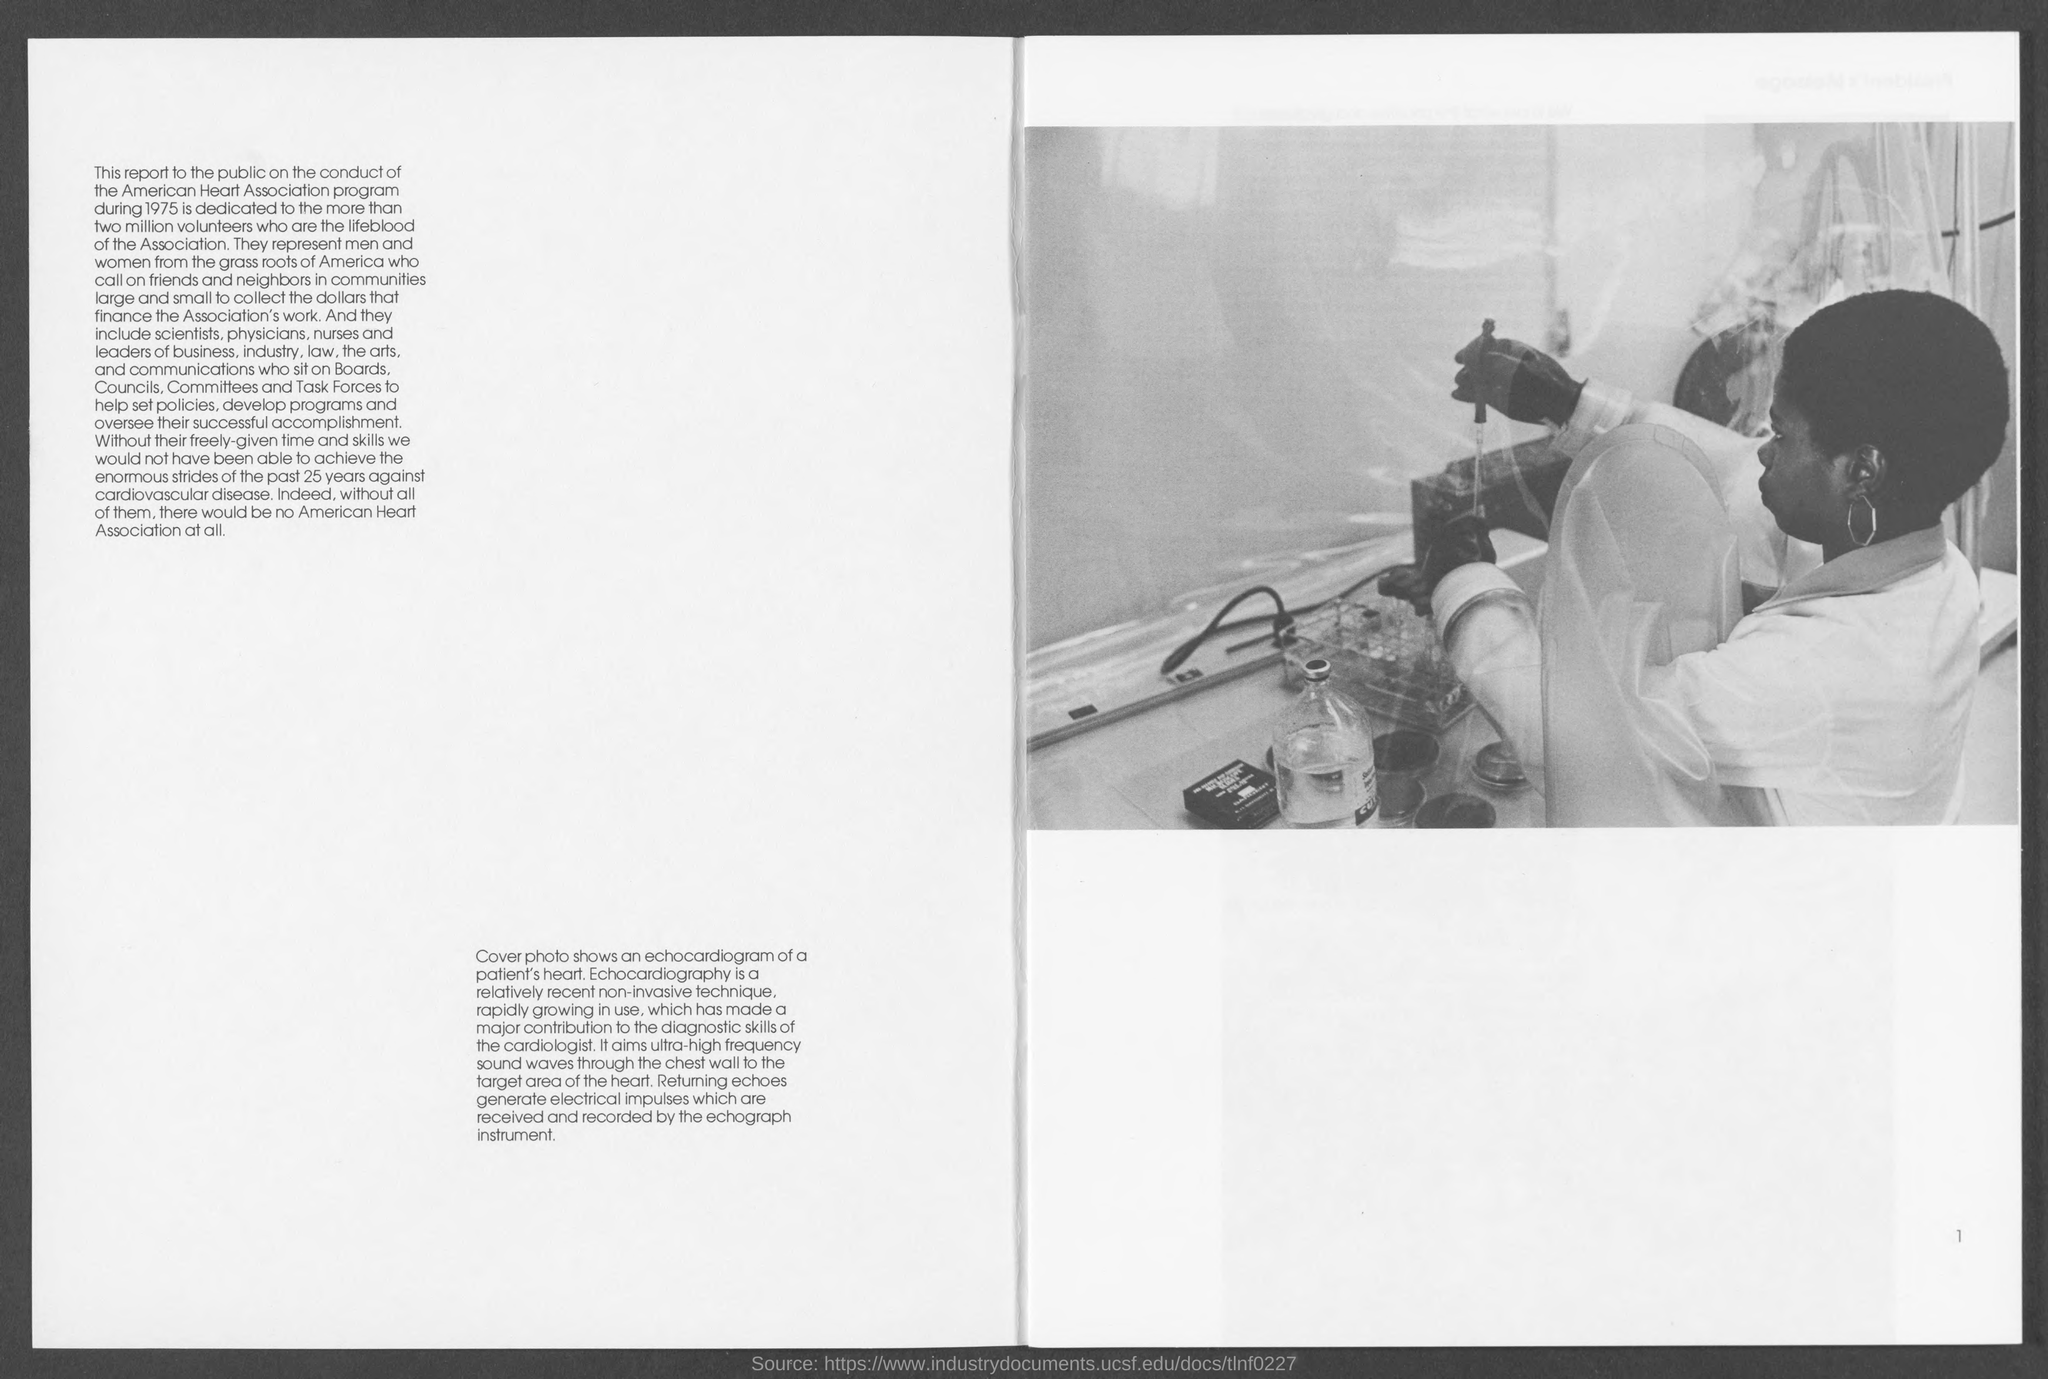Identify some key points in this picture. Echocardiography uses ultra-high frequency sound waves to produce images of the heart's structure and function. The cover photo in this document depicts an echocardiogram of a patient's heart, which is a diagnostic imaging technique used to visualize the function and structure of the heart. The use of non-invasive echocardiography has significantly improved the diagnostic abilities of cardiologists and enhanced their ability to accurately diagnose and manage heart conditions. 